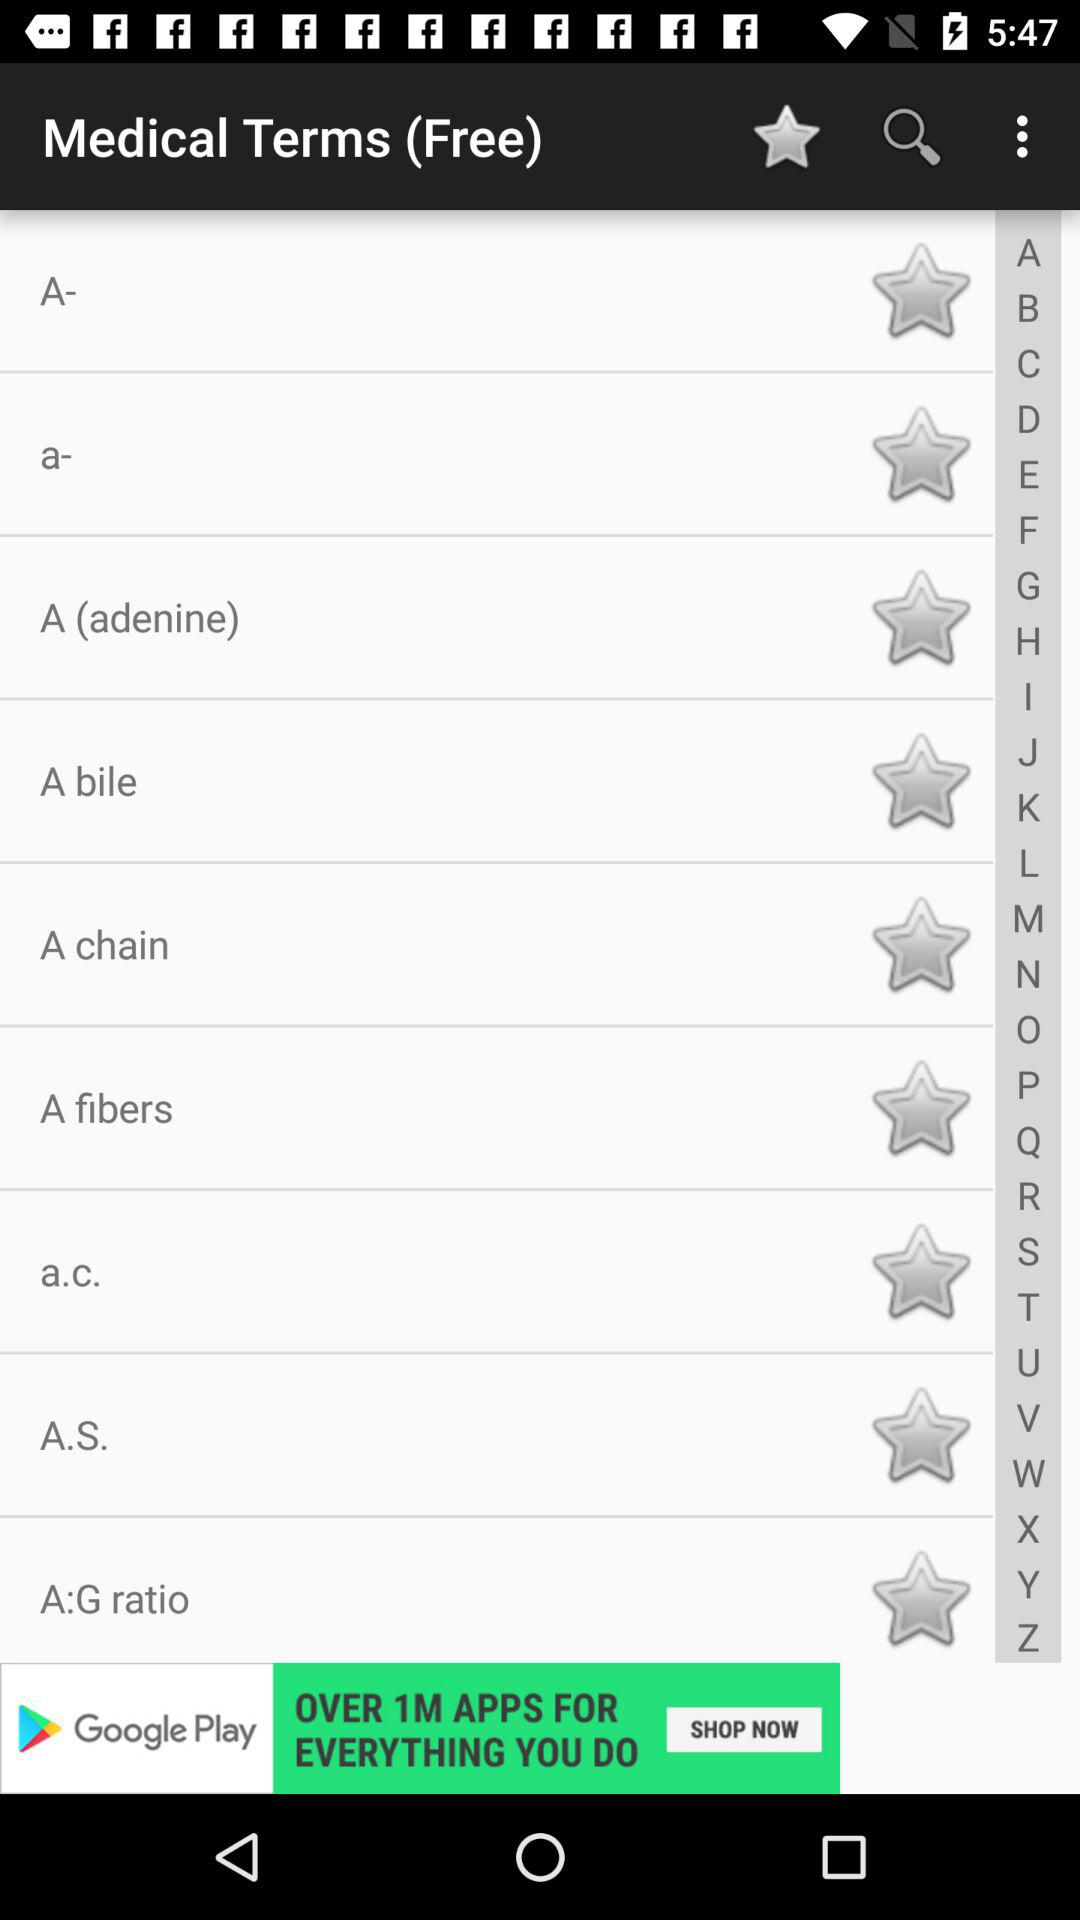What is the application name? The application name is "Medical Terms (Free)". 